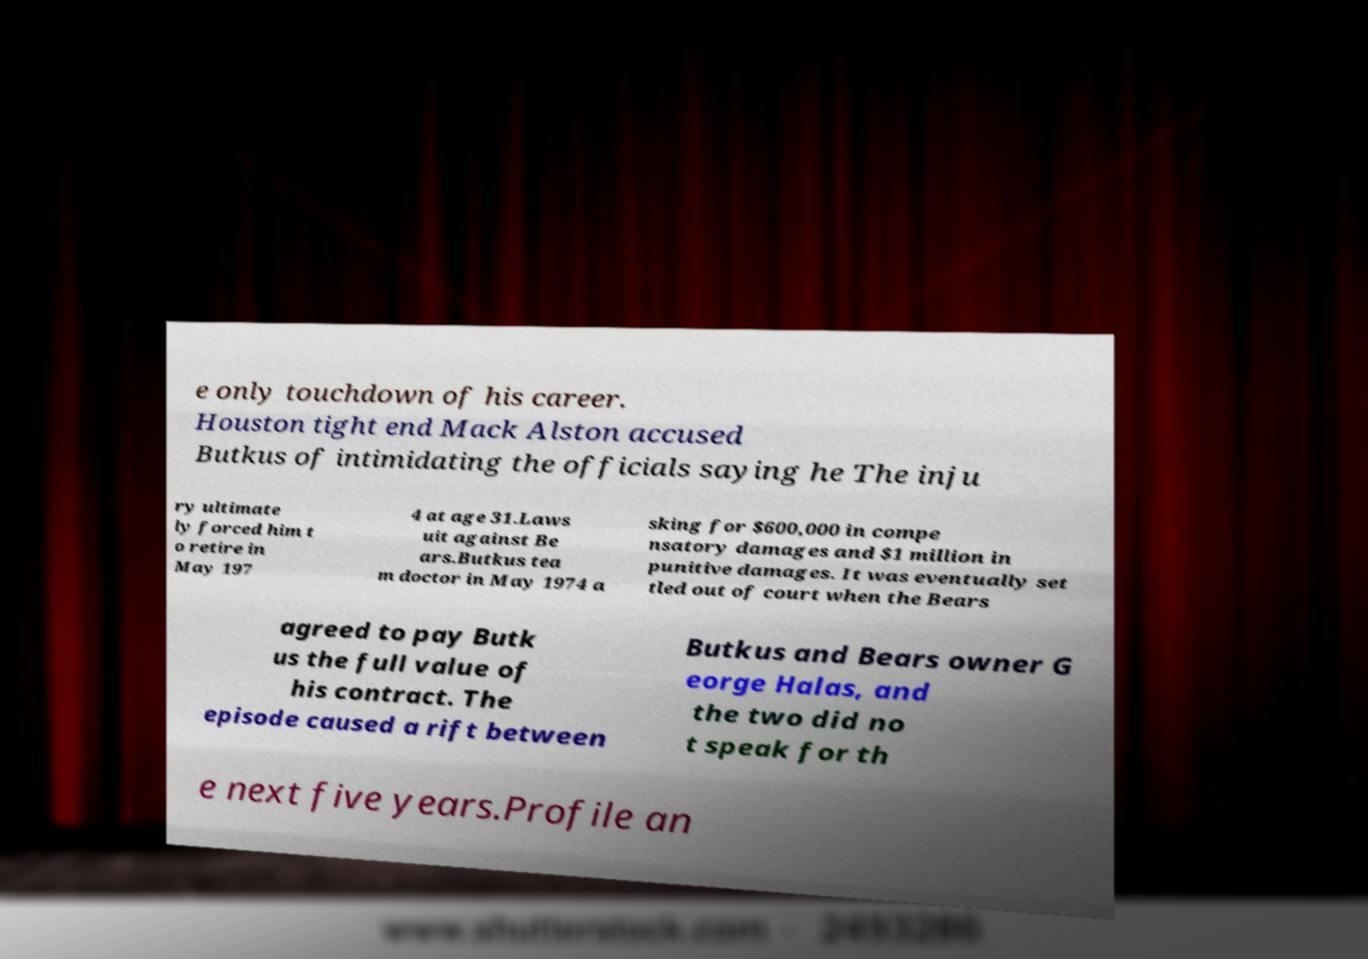I need the written content from this picture converted into text. Can you do that? e only touchdown of his career. Houston tight end Mack Alston accused Butkus of intimidating the officials saying he The inju ry ultimate ly forced him t o retire in May 197 4 at age 31.Laws uit against Be ars.Butkus tea m doctor in May 1974 a sking for $600,000 in compe nsatory damages and $1 million in punitive damages. It was eventually set tled out of court when the Bears agreed to pay Butk us the full value of his contract. The episode caused a rift between Butkus and Bears owner G eorge Halas, and the two did no t speak for th e next five years.Profile an 